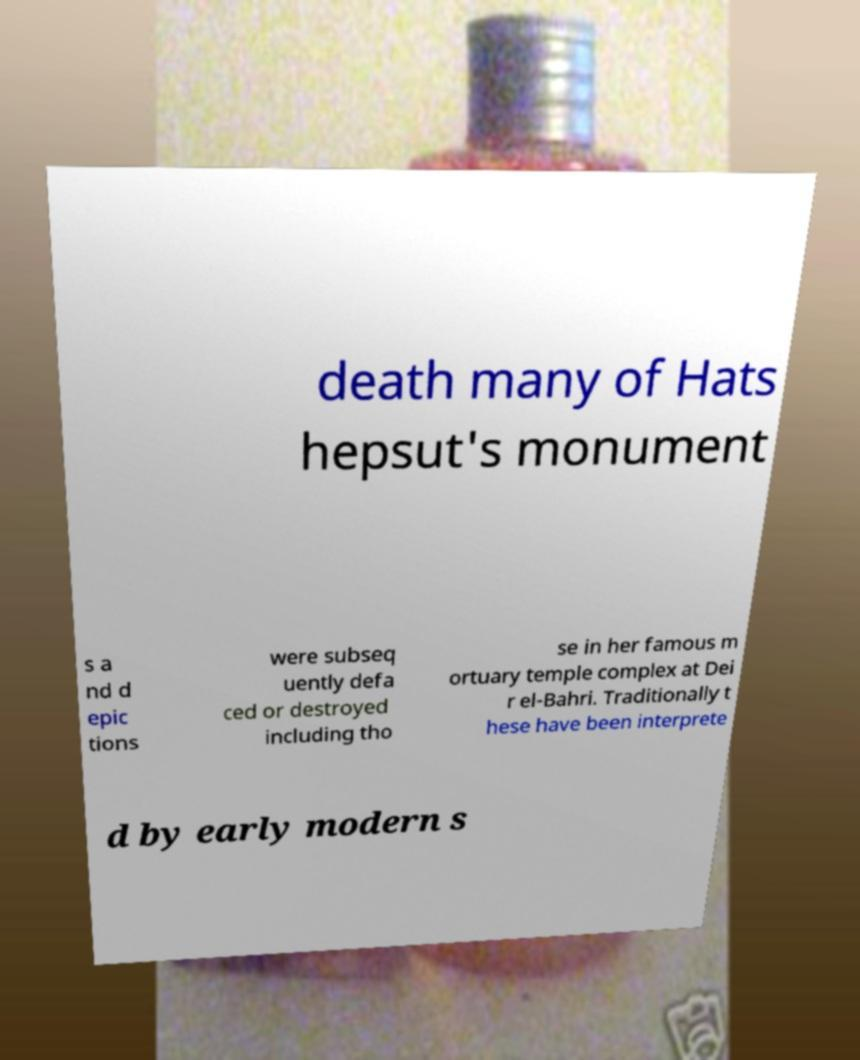Please read and relay the text visible in this image. What does it say? death many of Hats hepsut's monument s a nd d epic tions were subseq uently defa ced or destroyed including tho se in her famous m ortuary temple complex at Dei r el-Bahri. Traditionally t hese have been interprete d by early modern s 